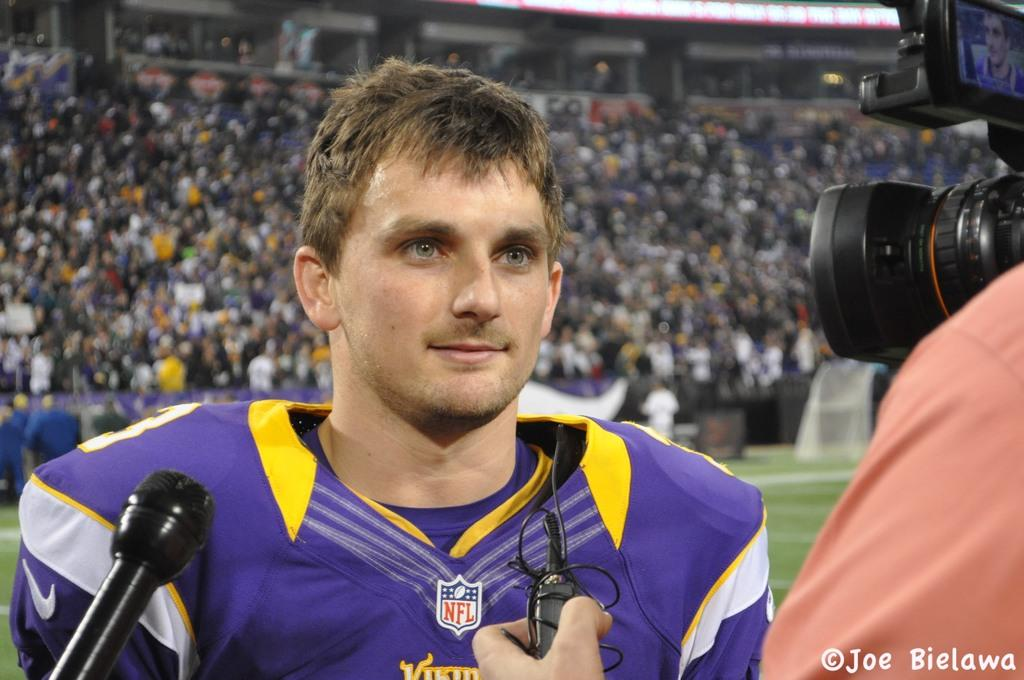<image>
Share a concise interpretation of the image provided. Man getting interviewied wearing a jersey which says NFL on it. 